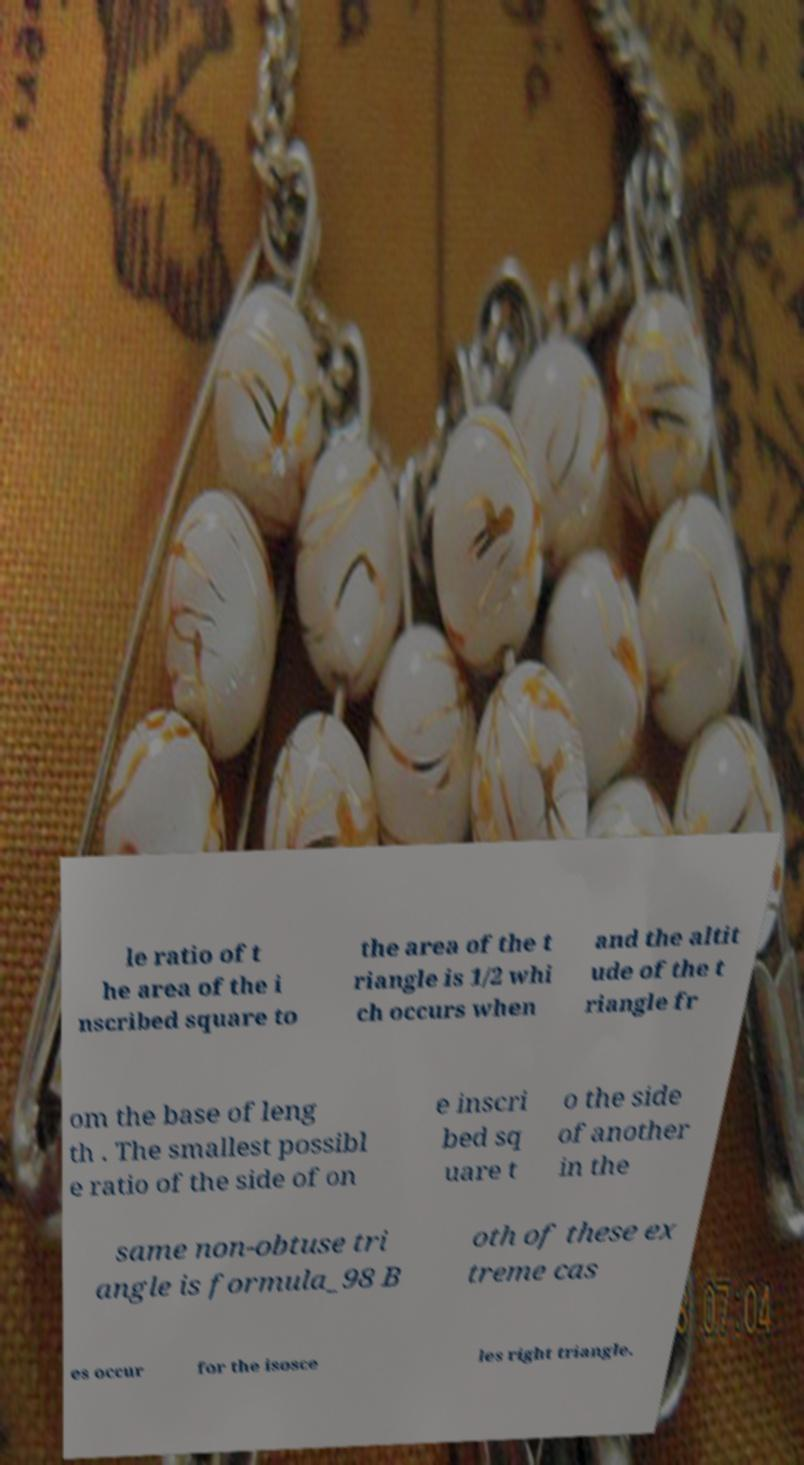Can you read and provide the text displayed in the image?This photo seems to have some interesting text. Can you extract and type it out for me? le ratio of t he area of the i nscribed square to the area of the t riangle is 1/2 whi ch occurs when and the altit ude of the t riangle fr om the base of leng th . The smallest possibl e ratio of the side of on e inscri bed sq uare t o the side of another in the same non-obtuse tri angle is formula_98 B oth of these ex treme cas es occur for the isosce les right triangle. 